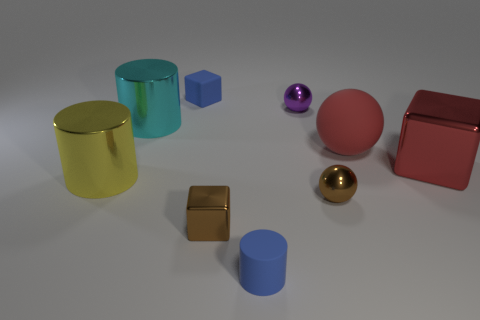Subtract 1 balls. How many balls are left? 2 Add 1 brown blocks. How many objects exist? 10 Subtract all cylinders. How many objects are left? 6 Subtract 1 blue cylinders. How many objects are left? 8 Subtract all purple metal cylinders. Subtract all small brown shiny things. How many objects are left? 7 Add 7 small blocks. How many small blocks are left? 9 Add 4 large red balls. How many large red balls exist? 5 